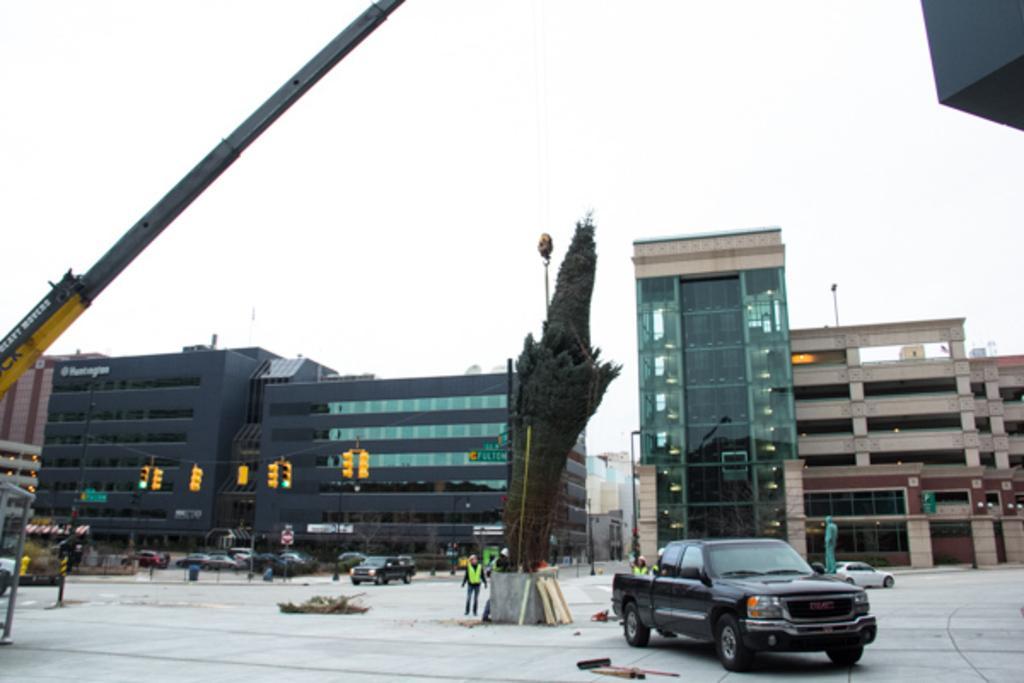How would you summarize this image in a sentence or two? In the center of the picture there are buildings, signals, cars and people. In the foreground there are wood material, tree crane and a car. Sky is cloudy. 